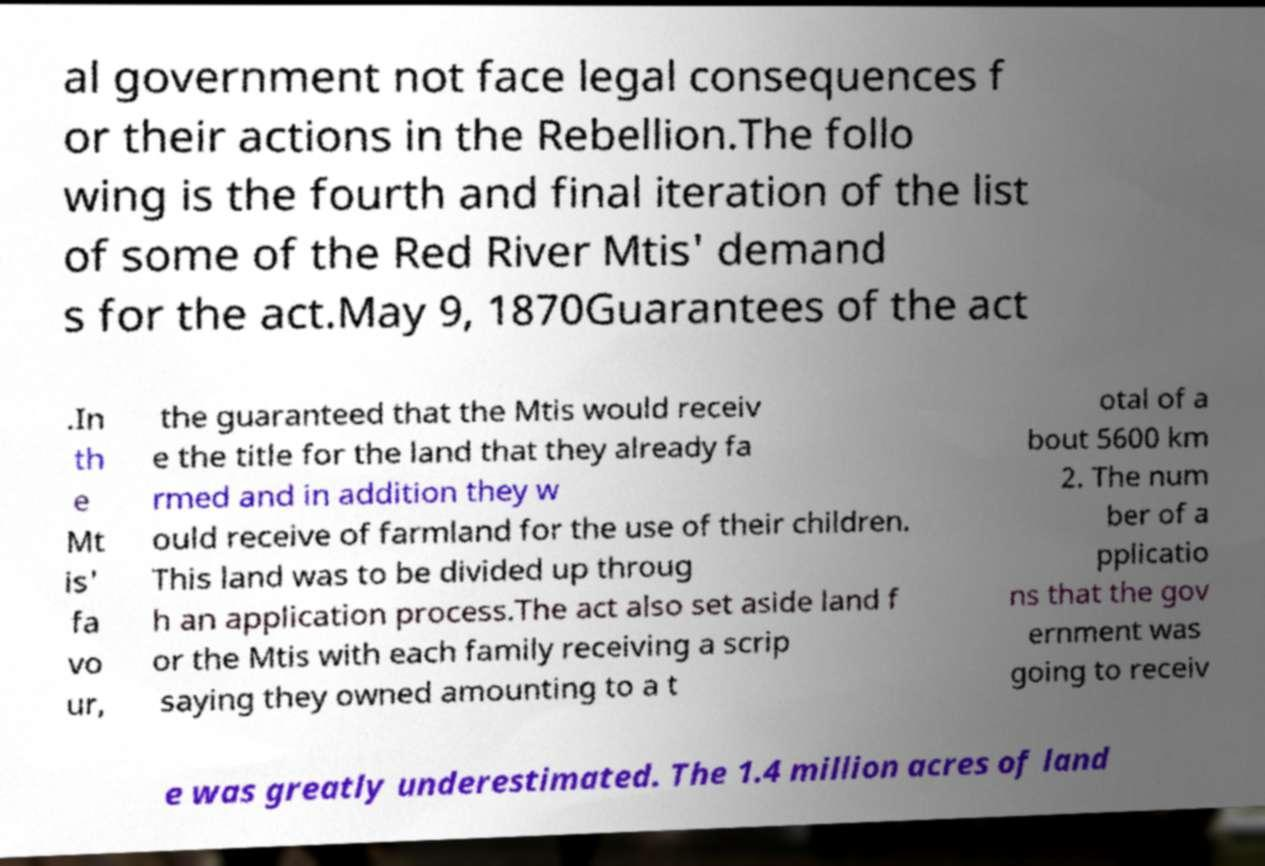What messages or text are displayed in this image? I need them in a readable, typed format. al government not face legal consequences f or their actions in the Rebellion.The follo wing is the fourth and final iteration of the list of some of the Red River Mtis' demand s for the act.May 9, 1870Guarantees of the act .In th e Mt is' fa vo ur, the guaranteed that the Mtis would receiv e the title for the land that they already fa rmed and in addition they w ould receive of farmland for the use of their children. This land was to be divided up throug h an application process.The act also set aside land f or the Mtis with each family receiving a scrip saying they owned amounting to a t otal of a bout 5600 km 2. The num ber of a pplicatio ns that the gov ernment was going to receiv e was greatly underestimated. The 1.4 million acres of land 